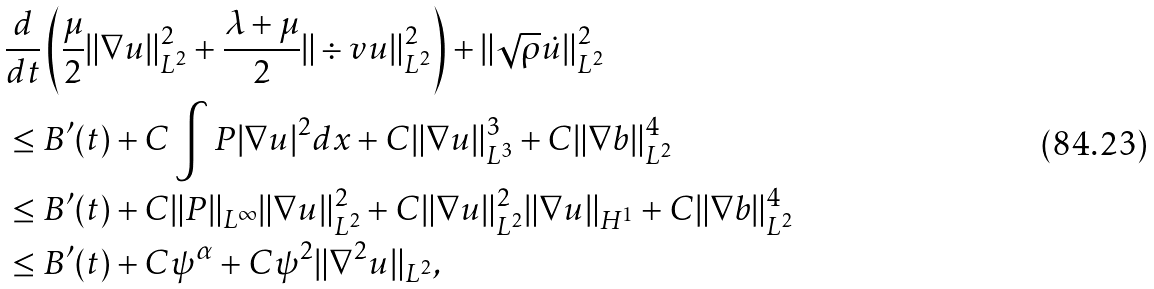<formula> <loc_0><loc_0><loc_500><loc_500>& \frac { d } { d t } \left ( \frac { \mu } { 2 } \| \nabla u \| _ { L ^ { 2 } } ^ { 2 } + \frac { \lambda + \mu } { 2 } \| \div v u \| _ { L ^ { 2 } } ^ { 2 } \right ) + \| \sqrt { \rho } \dot { u } \| _ { L ^ { 2 } } ^ { 2 } \\ & \leq B ^ { \prime } ( t ) + C \int P | \nabla u | ^ { 2 } d x + C \| \nabla u \| _ { L ^ { 3 } } ^ { 3 } + C \| \nabla b \| _ { L ^ { 2 } } ^ { 4 } \\ & \leq B ^ { \prime } ( t ) + C \| P \| _ { L ^ { \infty } } \| \nabla u \| _ { L ^ { 2 } } ^ { 2 } + C \| \nabla u \| _ { L ^ { 2 } } ^ { 2 } \| \nabla u \| _ { H ^ { 1 } } + C \| \nabla b \| _ { L ^ { 2 } } ^ { 4 } \\ & \leq B ^ { \prime } ( t ) + C \psi ^ { \alpha } + C \psi ^ { 2 } \| \nabla ^ { 2 } u \| _ { L ^ { 2 } } ,</formula> 